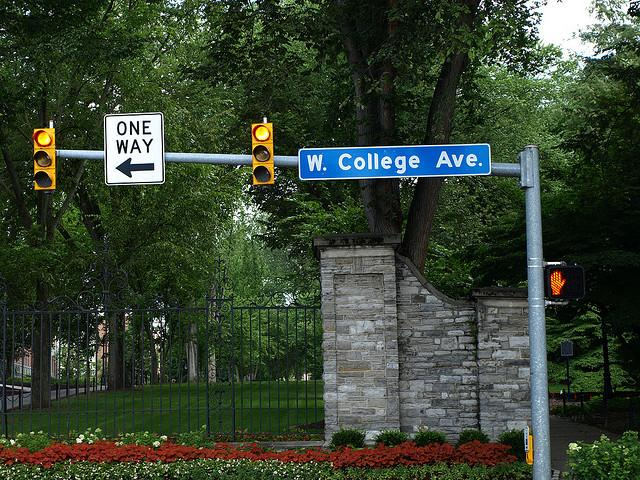What color is the light shown on top of the traffic lights of College Avenue? Please explain your reasoning. yellow. The colour of the light is the same as the thing around it, which is yellow. 